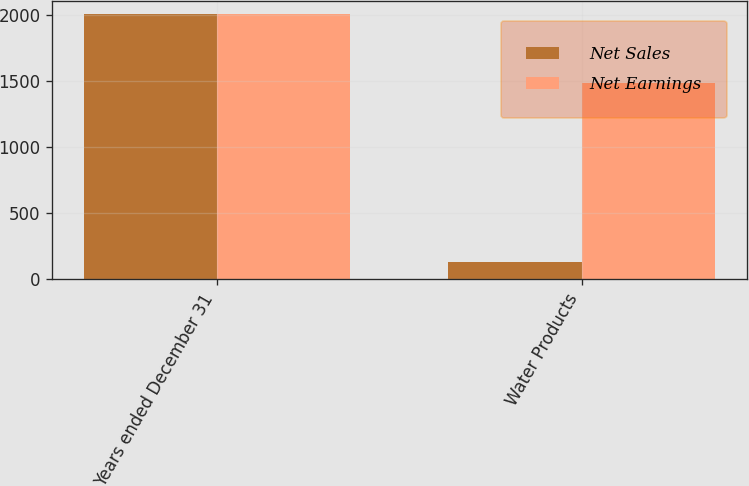<chart> <loc_0><loc_0><loc_500><loc_500><stacked_bar_chart><ecel><fcel>Years ended December 31<fcel>Water Products<nl><fcel>Net Sales<fcel>2010<fcel>132.9<nl><fcel>Net Earnings<fcel>2010<fcel>1489.3<nl></chart> 